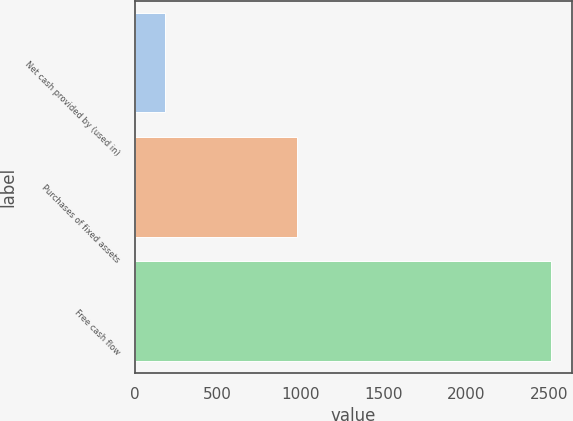Convert chart. <chart><loc_0><loc_0><loc_500><loc_500><bar_chart><fcel>Net cash provided by (used in)<fcel>Purchases of fixed assets<fcel>Free cash flow<nl><fcel>181<fcel>979<fcel>2516<nl></chart> 